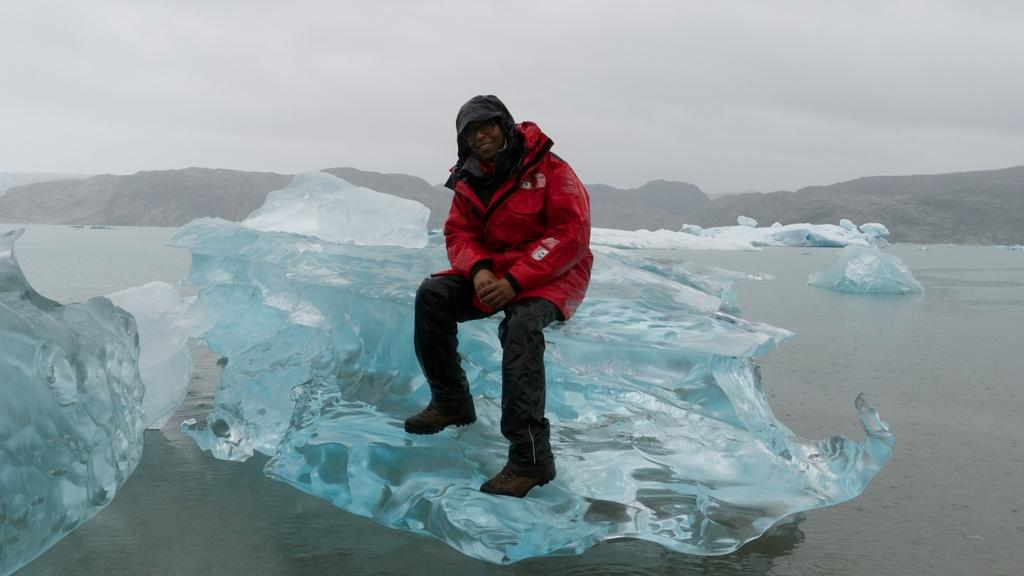What is the man in the image sitting on? The man is sitting on an iceberg in the image. What can be seen in the background of the image? There is water, hills, and the sky visible in the background of the image. What type of horn can be seen on the rabbit in the image? There is no rabbit present in the image, and therefore no horn can be seen. How many islands are visible in the image? There is no island visible in the image; it features a man sitting on an iceberg with water, hills, and the sky in the background. 